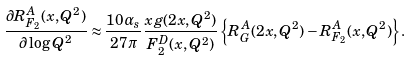<formula> <loc_0><loc_0><loc_500><loc_500>\frac { \partial R _ { F _ { 2 } } ^ { A } ( x , Q ^ { 2 } ) } { \partial \log Q ^ { 2 } } \approx \frac { 1 0 \alpha _ { s } } { 2 7 \pi } \frac { x g ( 2 x , Q ^ { 2 } ) } { F _ { 2 } ^ { D } ( x , Q ^ { 2 } ) } \left \{ R _ { G } ^ { A } ( 2 x , Q ^ { 2 } ) - R _ { F _ { 2 } } ^ { A } ( x , Q ^ { 2 } ) \right \} .</formula> 